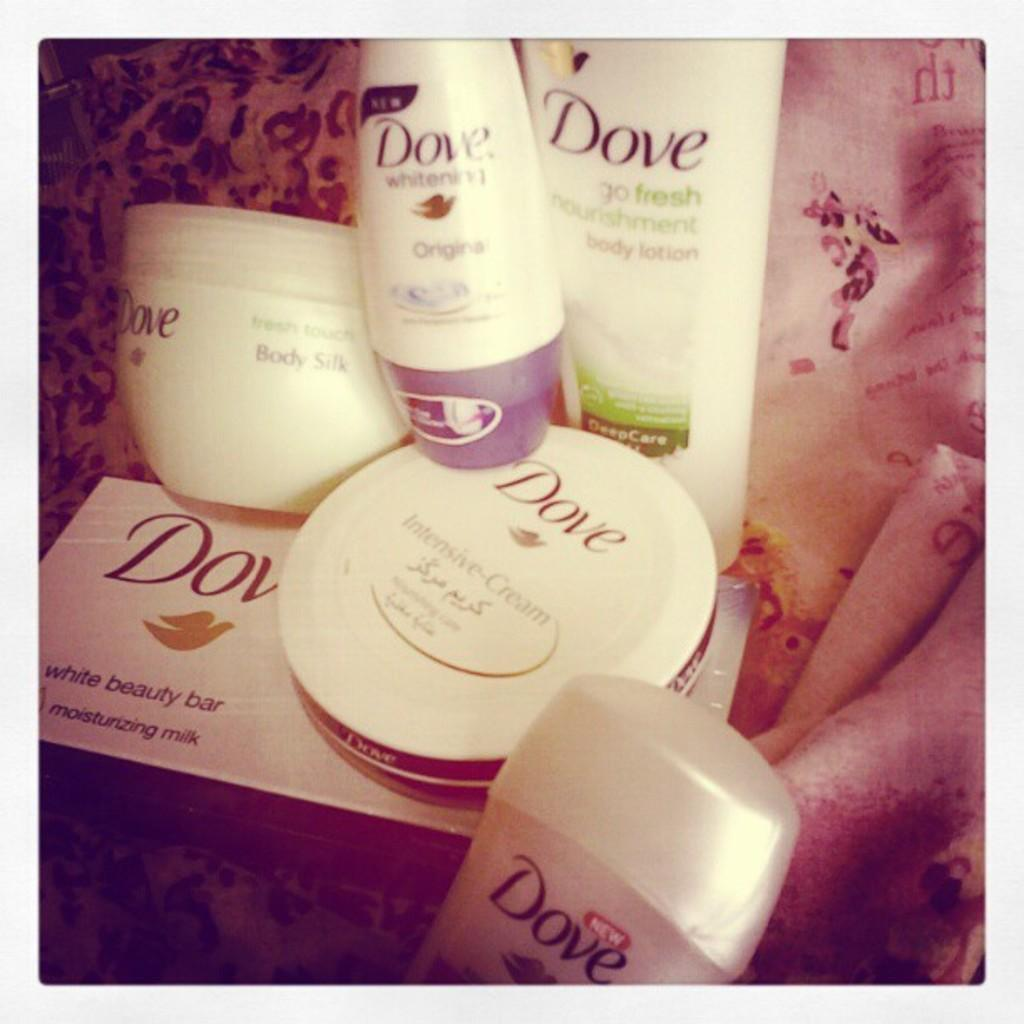<image>
Create a compact narrative representing the image presented. An array of different Dove products grouped together like deodorant and body lotion. 